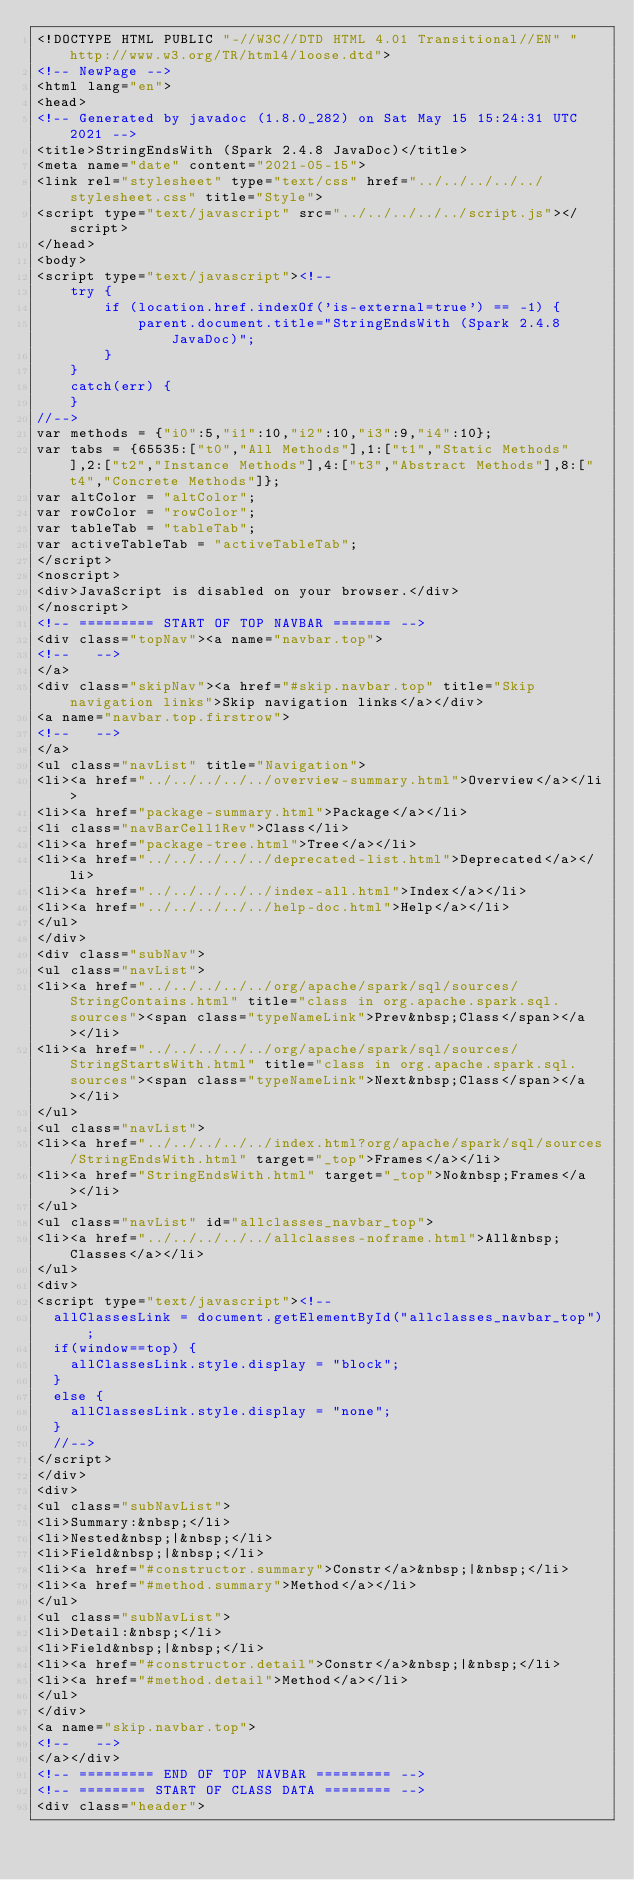Convert code to text. <code><loc_0><loc_0><loc_500><loc_500><_HTML_><!DOCTYPE HTML PUBLIC "-//W3C//DTD HTML 4.01 Transitional//EN" "http://www.w3.org/TR/html4/loose.dtd">
<!-- NewPage -->
<html lang="en">
<head>
<!-- Generated by javadoc (1.8.0_282) on Sat May 15 15:24:31 UTC 2021 -->
<title>StringEndsWith (Spark 2.4.8 JavaDoc)</title>
<meta name="date" content="2021-05-15">
<link rel="stylesheet" type="text/css" href="../../../../../stylesheet.css" title="Style">
<script type="text/javascript" src="../../../../../script.js"></script>
</head>
<body>
<script type="text/javascript"><!--
    try {
        if (location.href.indexOf('is-external=true') == -1) {
            parent.document.title="StringEndsWith (Spark 2.4.8 JavaDoc)";
        }
    }
    catch(err) {
    }
//-->
var methods = {"i0":5,"i1":10,"i2":10,"i3":9,"i4":10};
var tabs = {65535:["t0","All Methods"],1:["t1","Static Methods"],2:["t2","Instance Methods"],4:["t3","Abstract Methods"],8:["t4","Concrete Methods"]};
var altColor = "altColor";
var rowColor = "rowColor";
var tableTab = "tableTab";
var activeTableTab = "activeTableTab";
</script>
<noscript>
<div>JavaScript is disabled on your browser.</div>
</noscript>
<!-- ========= START OF TOP NAVBAR ======= -->
<div class="topNav"><a name="navbar.top">
<!--   -->
</a>
<div class="skipNav"><a href="#skip.navbar.top" title="Skip navigation links">Skip navigation links</a></div>
<a name="navbar.top.firstrow">
<!--   -->
</a>
<ul class="navList" title="Navigation">
<li><a href="../../../../../overview-summary.html">Overview</a></li>
<li><a href="package-summary.html">Package</a></li>
<li class="navBarCell1Rev">Class</li>
<li><a href="package-tree.html">Tree</a></li>
<li><a href="../../../../../deprecated-list.html">Deprecated</a></li>
<li><a href="../../../../../index-all.html">Index</a></li>
<li><a href="../../../../../help-doc.html">Help</a></li>
</ul>
</div>
<div class="subNav">
<ul class="navList">
<li><a href="../../../../../org/apache/spark/sql/sources/StringContains.html" title="class in org.apache.spark.sql.sources"><span class="typeNameLink">Prev&nbsp;Class</span></a></li>
<li><a href="../../../../../org/apache/spark/sql/sources/StringStartsWith.html" title="class in org.apache.spark.sql.sources"><span class="typeNameLink">Next&nbsp;Class</span></a></li>
</ul>
<ul class="navList">
<li><a href="../../../../../index.html?org/apache/spark/sql/sources/StringEndsWith.html" target="_top">Frames</a></li>
<li><a href="StringEndsWith.html" target="_top">No&nbsp;Frames</a></li>
</ul>
<ul class="navList" id="allclasses_navbar_top">
<li><a href="../../../../../allclasses-noframe.html">All&nbsp;Classes</a></li>
</ul>
<div>
<script type="text/javascript"><!--
  allClassesLink = document.getElementById("allclasses_navbar_top");
  if(window==top) {
    allClassesLink.style.display = "block";
  }
  else {
    allClassesLink.style.display = "none";
  }
  //-->
</script>
</div>
<div>
<ul class="subNavList">
<li>Summary:&nbsp;</li>
<li>Nested&nbsp;|&nbsp;</li>
<li>Field&nbsp;|&nbsp;</li>
<li><a href="#constructor.summary">Constr</a>&nbsp;|&nbsp;</li>
<li><a href="#method.summary">Method</a></li>
</ul>
<ul class="subNavList">
<li>Detail:&nbsp;</li>
<li>Field&nbsp;|&nbsp;</li>
<li><a href="#constructor.detail">Constr</a>&nbsp;|&nbsp;</li>
<li><a href="#method.detail">Method</a></li>
</ul>
</div>
<a name="skip.navbar.top">
<!--   -->
</a></div>
<!-- ========= END OF TOP NAVBAR ========= -->
<!-- ======== START OF CLASS DATA ======== -->
<div class="header"></code> 